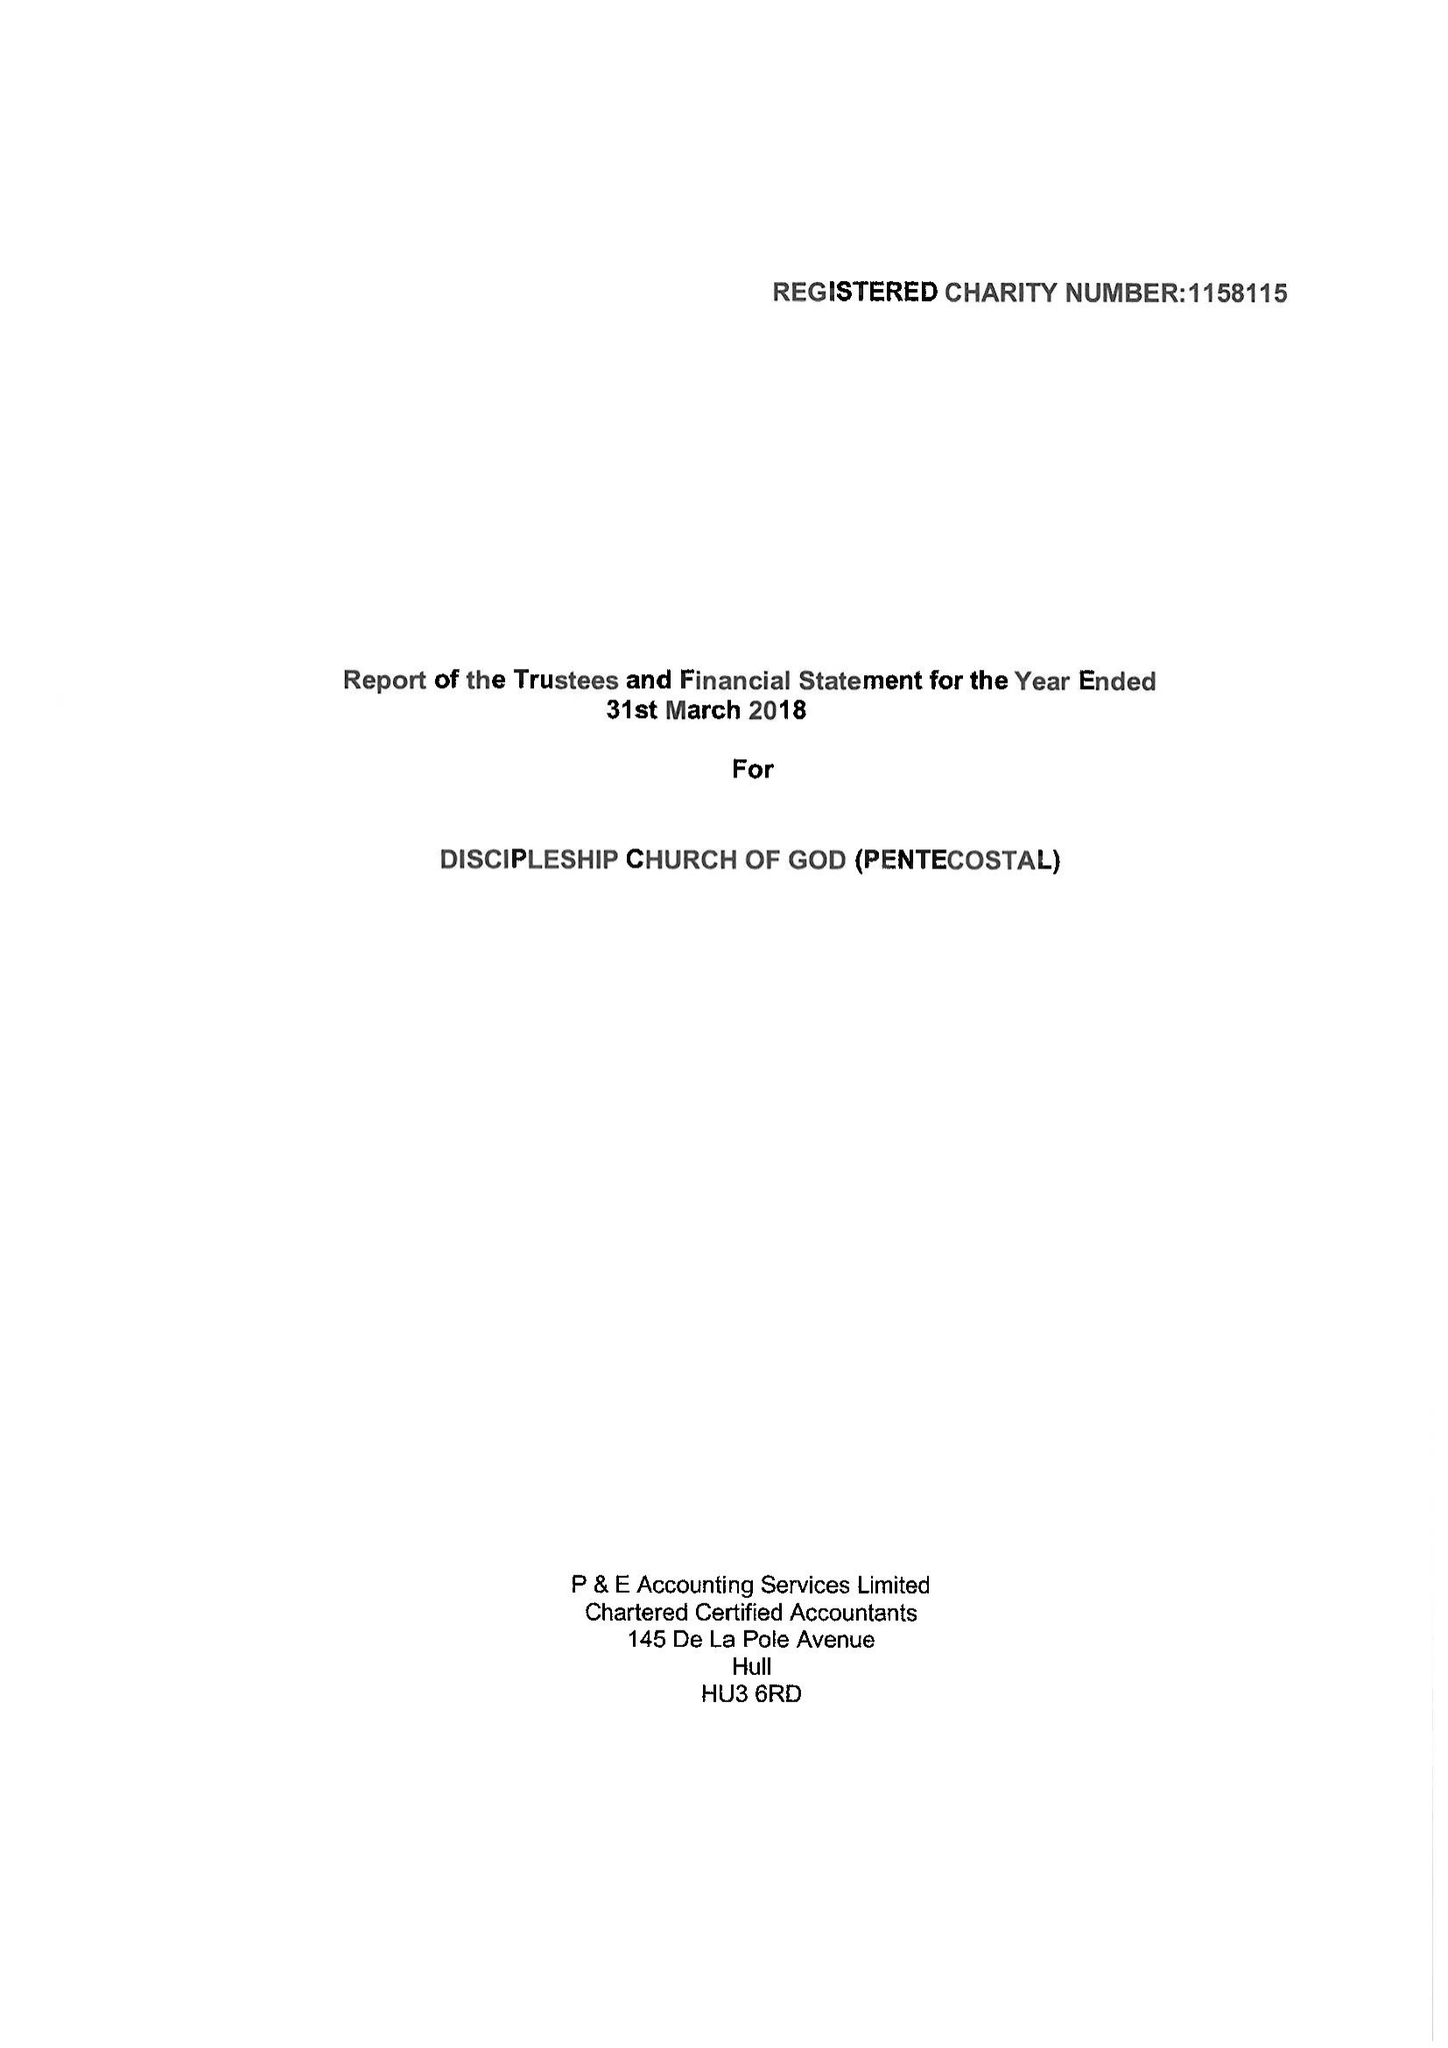What is the value for the address__street_line?
Answer the question using a single word or phrase. 96 LOMOND GROVE 